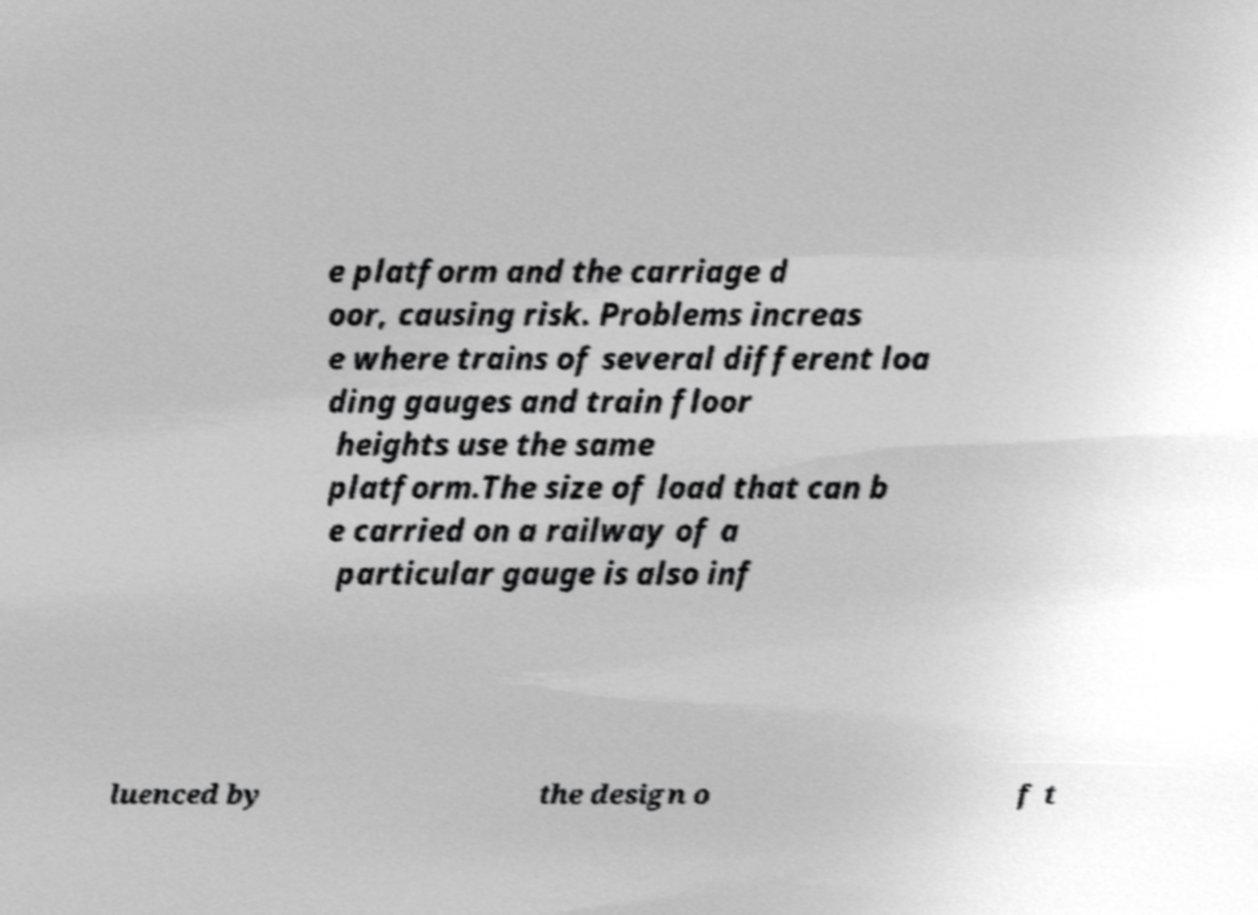Please read and relay the text visible in this image. What does it say? e platform and the carriage d oor, causing risk. Problems increas e where trains of several different loa ding gauges and train floor heights use the same platform.The size of load that can b e carried on a railway of a particular gauge is also inf luenced by the design o f t 